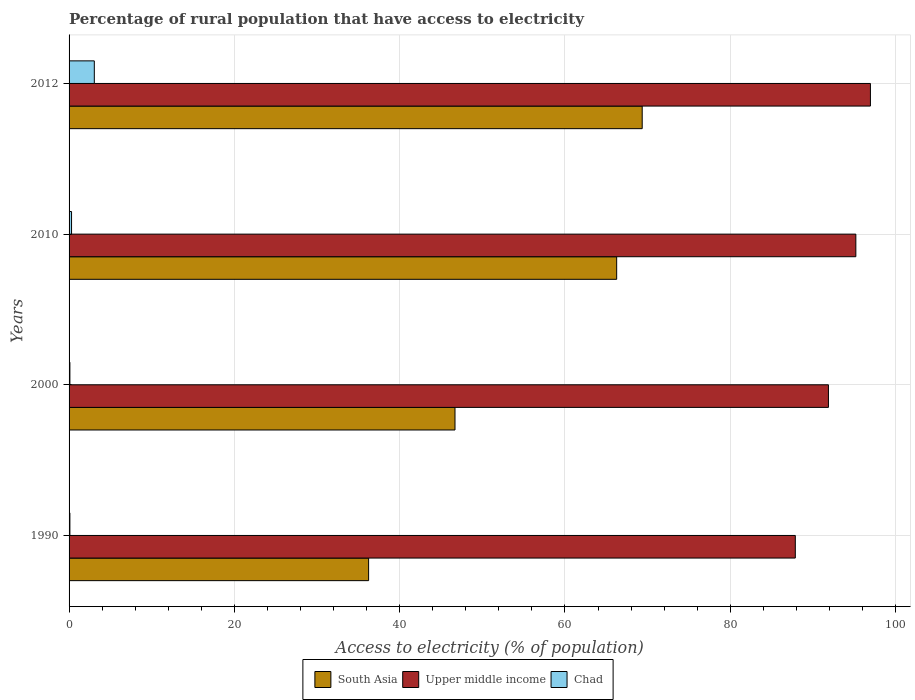How many groups of bars are there?
Keep it short and to the point. 4. Are the number of bars per tick equal to the number of legend labels?
Your answer should be compact. Yes. Are the number of bars on each tick of the Y-axis equal?
Your answer should be compact. Yes. How many bars are there on the 3rd tick from the top?
Your answer should be compact. 3. In how many cases, is the number of bars for a given year not equal to the number of legend labels?
Your answer should be compact. 0. What is the percentage of rural population that have access to electricity in Chad in 2012?
Keep it short and to the point. 3.05. Across all years, what is the maximum percentage of rural population that have access to electricity in South Asia?
Provide a succinct answer. 69.34. Across all years, what is the minimum percentage of rural population that have access to electricity in South Asia?
Your answer should be compact. 36.24. What is the total percentage of rural population that have access to electricity in South Asia in the graph?
Make the answer very short. 218.53. What is the difference between the percentage of rural population that have access to electricity in Chad in 1990 and that in 2010?
Ensure brevity in your answer.  -0.2. What is the difference between the percentage of rural population that have access to electricity in Upper middle income in 2000 and the percentage of rural population that have access to electricity in Chad in 2012?
Keep it short and to the point. 88.82. What is the average percentage of rural population that have access to electricity in Upper middle income per year?
Keep it short and to the point. 92.97. In the year 2000, what is the difference between the percentage of rural population that have access to electricity in Chad and percentage of rural population that have access to electricity in South Asia?
Offer a terse response. -46.59. What is the ratio of the percentage of rural population that have access to electricity in Upper middle income in 1990 to that in 2010?
Your answer should be compact. 0.92. Is the percentage of rural population that have access to electricity in Chad in 1990 less than that in 2010?
Provide a short and direct response. Yes. What is the difference between the highest and the second highest percentage of rural population that have access to electricity in Chad?
Your response must be concise. 2.75. What is the difference between the highest and the lowest percentage of rural population that have access to electricity in Upper middle income?
Keep it short and to the point. 9.09. What does the 1st bar from the top in 1990 represents?
Make the answer very short. Chad. What does the 3rd bar from the bottom in 2010 represents?
Ensure brevity in your answer.  Chad. Is it the case that in every year, the sum of the percentage of rural population that have access to electricity in Upper middle income and percentage of rural population that have access to electricity in Chad is greater than the percentage of rural population that have access to electricity in South Asia?
Offer a very short reply. Yes. Are the values on the major ticks of X-axis written in scientific E-notation?
Your answer should be compact. No. What is the title of the graph?
Make the answer very short. Percentage of rural population that have access to electricity. What is the label or title of the X-axis?
Make the answer very short. Access to electricity (% of population). What is the label or title of the Y-axis?
Offer a terse response. Years. What is the Access to electricity (% of population) of South Asia in 1990?
Provide a short and direct response. 36.24. What is the Access to electricity (% of population) in Upper middle income in 1990?
Your answer should be compact. 87.87. What is the Access to electricity (% of population) in Chad in 1990?
Make the answer very short. 0.1. What is the Access to electricity (% of population) in South Asia in 2000?
Give a very brief answer. 46.69. What is the Access to electricity (% of population) in Upper middle income in 2000?
Your answer should be compact. 91.87. What is the Access to electricity (% of population) in South Asia in 2010?
Offer a very short reply. 66.25. What is the Access to electricity (% of population) of Upper middle income in 2010?
Ensure brevity in your answer.  95.19. What is the Access to electricity (% of population) of South Asia in 2012?
Provide a short and direct response. 69.34. What is the Access to electricity (% of population) in Upper middle income in 2012?
Make the answer very short. 96.95. What is the Access to electricity (% of population) in Chad in 2012?
Your response must be concise. 3.05. Across all years, what is the maximum Access to electricity (% of population) of South Asia?
Provide a short and direct response. 69.34. Across all years, what is the maximum Access to electricity (% of population) in Upper middle income?
Provide a short and direct response. 96.95. Across all years, what is the maximum Access to electricity (% of population) of Chad?
Your response must be concise. 3.05. Across all years, what is the minimum Access to electricity (% of population) in South Asia?
Your response must be concise. 36.24. Across all years, what is the minimum Access to electricity (% of population) of Upper middle income?
Your response must be concise. 87.87. Across all years, what is the minimum Access to electricity (% of population) of Chad?
Give a very brief answer. 0.1. What is the total Access to electricity (% of population) of South Asia in the graph?
Your response must be concise. 218.53. What is the total Access to electricity (% of population) in Upper middle income in the graph?
Your answer should be very brief. 371.89. What is the total Access to electricity (% of population) in Chad in the graph?
Keep it short and to the point. 3.55. What is the difference between the Access to electricity (% of population) of South Asia in 1990 and that in 2000?
Keep it short and to the point. -10.45. What is the difference between the Access to electricity (% of population) of Upper middle income in 1990 and that in 2000?
Give a very brief answer. -4.01. What is the difference between the Access to electricity (% of population) in South Asia in 1990 and that in 2010?
Offer a very short reply. -30.01. What is the difference between the Access to electricity (% of population) in Upper middle income in 1990 and that in 2010?
Give a very brief answer. -7.32. What is the difference between the Access to electricity (% of population) of Chad in 1990 and that in 2010?
Provide a succinct answer. -0.2. What is the difference between the Access to electricity (% of population) of South Asia in 1990 and that in 2012?
Provide a short and direct response. -33.1. What is the difference between the Access to electricity (% of population) of Upper middle income in 1990 and that in 2012?
Keep it short and to the point. -9.09. What is the difference between the Access to electricity (% of population) in Chad in 1990 and that in 2012?
Ensure brevity in your answer.  -2.95. What is the difference between the Access to electricity (% of population) of South Asia in 2000 and that in 2010?
Your response must be concise. -19.56. What is the difference between the Access to electricity (% of population) in Upper middle income in 2000 and that in 2010?
Keep it short and to the point. -3.32. What is the difference between the Access to electricity (% of population) in Chad in 2000 and that in 2010?
Your answer should be compact. -0.2. What is the difference between the Access to electricity (% of population) in South Asia in 2000 and that in 2012?
Your answer should be compact. -22.65. What is the difference between the Access to electricity (% of population) of Upper middle income in 2000 and that in 2012?
Offer a very short reply. -5.08. What is the difference between the Access to electricity (% of population) in Chad in 2000 and that in 2012?
Your answer should be very brief. -2.95. What is the difference between the Access to electricity (% of population) in South Asia in 2010 and that in 2012?
Give a very brief answer. -3.09. What is the difference between the Access to electricity (% of population) in Upper middle income in 2010 and that in 2012?
Offer a terse response. -1.76. What is the difference between the Access to electricity (% of population) of Chad in 2010 and that in 2012?
Your response must be concise. -2.75. What is the difference between the Access to electricity (% of population) of South Asia in 1990 and the Access to electricity (% of population) of Upper middle income in 2000?
Your response must be concise. -55.63. What is the difference between the Access to electricity (% of population) of South Asia in 1990 and the Access to electricity (% of population) of Chad in 2000?
Your response must be concise. 36.14. What is the difference between the Access to electricity (% of population) of Upper middle income in 1990 and the Access to electricity (% of population) of Chad in 2000?
Give a very brief answer. 87.77. What is the difference between the Access to electricity (% of population) in South Asia in 1990 and the Access to electricity (% of population) in Upper middle income in 2010?
Provide a succinct answer. -58.95. What is the difference between the Access to electricity (% of population) in South Asia in 1990 and the Access to electricity (% of population) in Chad in 2010?
Offer a very short reply. 35.94. What is the difference between the Access to electricity (% of population) of Upper middle income in 1990 and the Access to electricity (% of population) of Chad in 2010?
Your response must be concise. 87.57. What is the difference between the Access to electricity (% of population) of South Asia in 1990 and the Access to electricity (% of population) of Upper middle income in 2012?
Ensure brevity in your answer.  -60.71. What is the difference between the Access to electricity (% of population) of South Asia in 1990 and the Access to electricity (% of population) of Chad in 2012?
Provide a short and direct response. 33.19. What is the difference between the Access to electricity (% of population) of Upper middle income in 1990 and the Access to electricity (% of population) of Chad in 2012?
Provide a short and direct response. 84.81. What is the difference between the Access to electricity (% of population) in South Asia in 2000 and the Access to electricity (% of population) in Upper middle income in 2010?
Provide a short and direct response. -48.5. What is the difference between the Access to electricity (% of population) of South Asia in 2000 and the Access to electricity (% of population) of Chad in 2010?
Give a very brief answer. 46.39. What is the difference between the Access to electricity (% of population) of Upper middle income in 2000 and the Access to electricity (% of population) of Chad in 2010?
Provide a succinct answer. 91.57. What is the difference between the Access to electricity (% of population) in South Asia in 2000 and the Access to electricity (% of population) in Upper middle income in 2012?
Your response must be concise. -50.26. What is the difference between the Access to electricity (% of population) in South Asia in 2000 and the Access to electricity (% of population) in Chad in 2012?
Give a very brief answer. 43.64. What is the difference between the Access to electricity (% of population) of Upper middle income in 2000 and the Access to electricity (% of population) of Chad in 2012?
Your answer should be very brief. 88.82. What is the difference between the Access to electricity (% of population) of South Asia in 2010 and the Access to electricity (% of population) of Upper middle income in 2012?
Your response must be concise. -30.7. What is the difference between the Access to electricity (% of population) of South Asia in 2010 and the Access to electricity (% of population) of Chad in 2012?
Offer a terse response. 63.2. What is the difference between the Access to electricity (% of population) in Upper middle income in 2010 and the Access to electricity (% of population) in Chad in 2012?
Make the answer very short. 92.14. What is the average Access to electricity (% of population) in South Asia per year?
Give a very brief answer. 54.63. What is the average Access to electricity (% of population) in Upper middle income per year?
Offer a very short reply. 92.97. What is the average Access to electricity (% of population) of Chad per year?
Ensure brevity in your answer.  0.89. In the year 1990, what is the difference between the Access to electricity (% of population) in South Asia and Access to electricity (% of population) in Upper middle income?
Offer a very short reply. -51.62. In the year 1990, what is the difference between the Access to electricity (% of population) of South Asia and Access to electricity (% of population) of Chad?
Your response must be concise. 36.14. In the year 1990, what is the difference between the Access to electricity (% of population) in Upper middle income and Access to electricity (% of population) in Chad?
Provide a succinct answer. 87.77. In the year 2000, what is the difference between the Access to electricity (% of population) of South Asia and Access to electricity (% of population) of Upper middle income?
Keep it short and to the point. -45.18. In the year 2000, what is the difference between the Access to electricity (% of population) in South Asia and Access to electricity (% of population) in Chad?
Your answer should be compact. 46.59. In the year 2000, what is the difference between the Access to electricity (% of population) in Upper middle income and Access to electricity (% of population) in Chad?
Provide a succinct answer. 91.77. In the year 2010, what is the difference between the Access to electricity (% of population) in South Asia and Access to electricity (% of population) in Upper middle income?
Give a very brief answer. -28.94. In the year 2010, what is the difference between the Access to electricity (% of population) in South Asia and Access to electricity (% of population) in Chad?
Give a very brief answer. 65.95. In the year 2010, what is the difference between the Access to electricity (% of population) of Upper middle income and Access to electricity (% of population) of Chad?
Provide a short and direct response. 94.89. In the year 2012, what is the difference between the Access to electricity (% of population) of South Asia and Access to electricity (% of population) of Upper middle income?
Give a very brief answer. -27.61. In the year 2012, what is the difference between the Access to electricity (% of population) in South Asia and Access to electricity (% of population) in Chad?
Provide a succinct answer. 66.29. In the year 2012, what is the difference between the Access to electricity (% of population) of Upper middle income and Access to electricity (% of population) of Chad?
Provide a short and direct response. 93.9. What is the ratio of the Access to electricity (% of population) of South Asia in 1990 to that in 2000?
Your response must be concise. 0.78. What is the ratio of the Access to electricity (% of population) of Upper middle income in 1990 to that in 2000?
Your answer should be compact. 0.96. What is the ratio of the Access to electricity (% of population) of South Asia in 1990 to that in 2010?
Provide a succinct answer. 0.55. What is the ratio of the Access to electricity (% of population) of South Asia in 1990 to that in 2012?
Keep it short and to the point. 0.52. What is the ratio of the Access to electricity (% of population) in Upper middle income in 1990 to that in 2012?
Offer a very short reply. 0.91. What is the ratio of the Access to electricity (% of population) in Chad in 1990 to that in 2012?
Offer a terse response. 0.03. What is the ratio of the Access to electricity (% of population) in South Asia in 2000 to that in 2010?
Keep it short and to the point. 0.7. What is the ratio of the Access to electricity (% of population) in Upper middle income in 2000 to that in 2010?
Your answer should be compact. 0.97. What is the ratio of the Access to electricity (% of population) of Chad in 2000 to that in 2010?
Your response must be concise. 0.33. What is the ratio of the Access to electricity (% of population) of South Asia in 2000 to that in 2012?
Offer a very short reply. 0.67. What is the ratio of the Access to electricity (% of population) in Upper middle income in 2000 to that in 2012?
Keep it short and to the point. 0.95. What is the ratio of the Access to electricity (% of population) of Chad in 2000 to that in 2012?
Your answer should be compact. 0.03. What is the ratio of the Access to electricity (% of population) of South Asia in 2010 to that in 2012?
Provide a succinct answer. 0.96. What is the ratio of the Access to electricity (% of population) of Upper middle income in 2010 to that in 2012?
Keep it short and to the point. 0.98. What is the ratio of the Access to electricity (% of population) of Chad in 2010 to that in 2012?
Ensure brevity in your answer.  0.1. What is the difference between the highest and the second highest Access to electricity (% of population) in South Asia?
Your answer should be compact. 3.09. What is the difference between the highest and the second highest Access to electricity (% of population) in Upper middle income?
Make the answer very short. 1.76. What is the difference between the highest and the second highest Access to electricity (% of population) of Chad?
Your response must be concise. 2.75. What is the difference between the highest and the lowest Access to electricity (% of population) of South Asia?
Make the answer very short. 33.1. What is the difference between the highest and the lowest Access to electricity (% of population) of Upper middle income?
Keep it short and to the point. 9.09. What is the difference between the highest and the lowest Access to electricity (% of population) of Chad?
Provide a succinct answer. 2.95. 